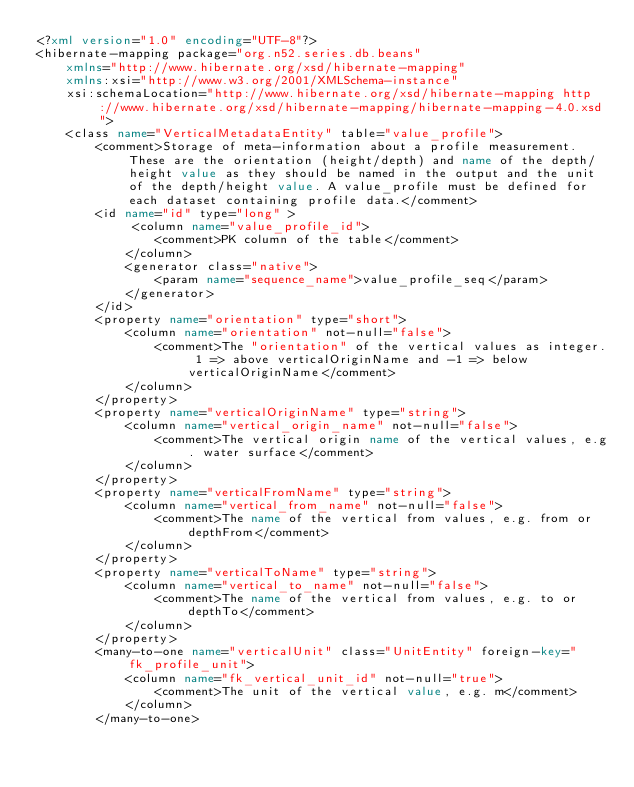Convert code to text. <code><loc_0><loc_0><loc_500><loc_500><_XML_><?xml version="1.0" encoding="UTF-8"?>
<hibernate-mapping package="org.n52.series.db.beans"
    xmlns="http://www.hibernate.org/xsd/hibernate-mapping"
    xmlns:xsi="http://www.w3.org/2001/XMLSchema-instance"
    xsi:schemaLocation="http://www.hibernate.org/xsd/hibernate-mapping http://www.hibernate.org/xsd/hibernate-mapping/hibernate-mapping-4.0.xsd">
    <class name="VerticalMetadataEntity" table="value_profile">
        <comment>Storage of meta-information about a profile measurement. These are the orientation (height/depth) and name of the depth/height value as they should be named in the output and the unit of the depth/height value. A value_profile must be defined for each dataset containing profile data.</comment>
        <id name="id" type="long" >
             <column name="value_profile_id">
                <comment>PK column of the table</comment>
            </column>
            <generator class="native">
                <param name="sequence_name">value_profile_seq</param>
            </generator>
        </id>
        <property name="orientation" type="short">
            <column name="orientation" not-null="false">
                <comment>The "orientation" of the vertical values as integer. 1 => above verticalOriginName and -1 => below verticalOriginName</comment>
            </column>
        </property>
        <property name="verticalOriginName" type="string">
            <column name="vertical_origin_name" not-null="false">
                <comment>The vertical origin name of the vertical values, e.g. water surface</comment>
            </column>
        </property>
        <property name="verticalFromName" type="string">
            <column name="vertical_from_name" not-null="false">
                <comment>The name of the vertical from values, e.g. from or depthFrom</comment>
            </column>
        </property>
        <property name="verticalToName" type="string">
            <column name="vertical_to_name" not-null="false">
                <comment>The name of the vertical from values, e.g. to or depthTo</comment>
            </column>
        </property>
        <many-to-one name="verticalUnit" class="UnitEntity" foreign-key="fk_profile_unit">
            <column name="fk_vertical_unit_id" not-null="true">
                <comment>The unit of the vertical value, e.g. m</comment>
            </column>
        </many-to-one></code> 